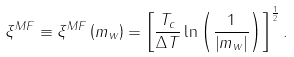Convert formula to latex. <formula><loc_0><loc_0><loc_500><loc_500>\xi ^ { M F } \equiv \xi ^ { M F } \left ( m _ { w } \right ) = \left [ \frac { T _ { c } } { \Delta T } \ln \left ( \frac { 1 } { \left | m _ { w } \right | } \right ) \right ] ^ { \frac { 1 } { 2 } } .</formula> 